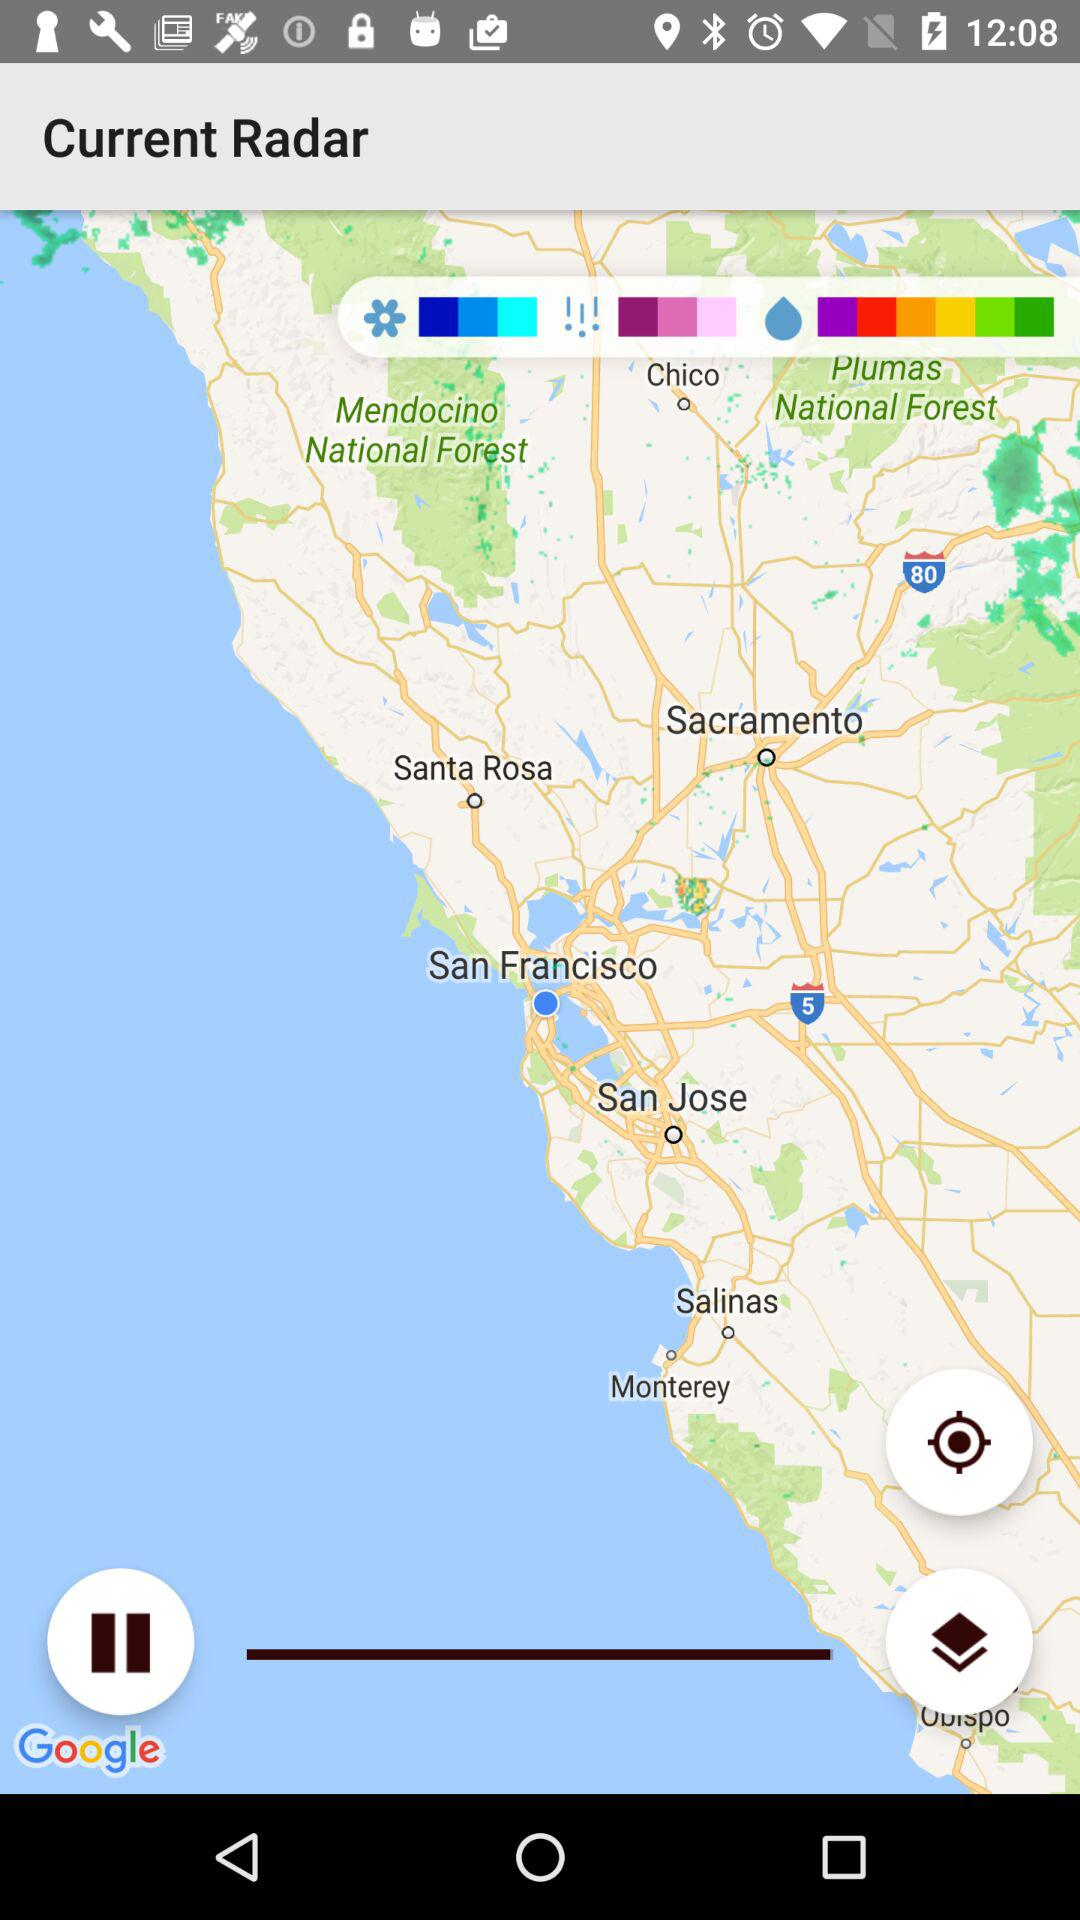What is the application name?
When the provided information is insufficient, respond with <no answer>. <no answer> 